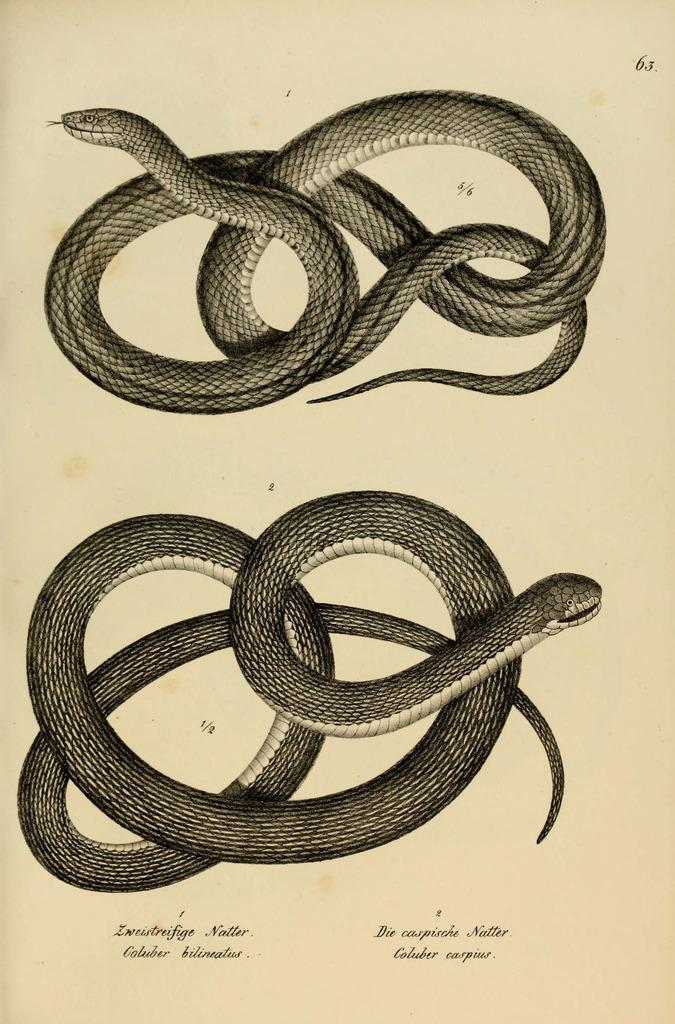What can be found at the bottom of the image? There is text at the bottom of the image. What is depicted in the middle of the image? There are images of snakes in the middle of the image. How many grips can be seen on the snakes in the image? There are no grips present on the snakes in the image, as they are depicted as images and not physical objects. 